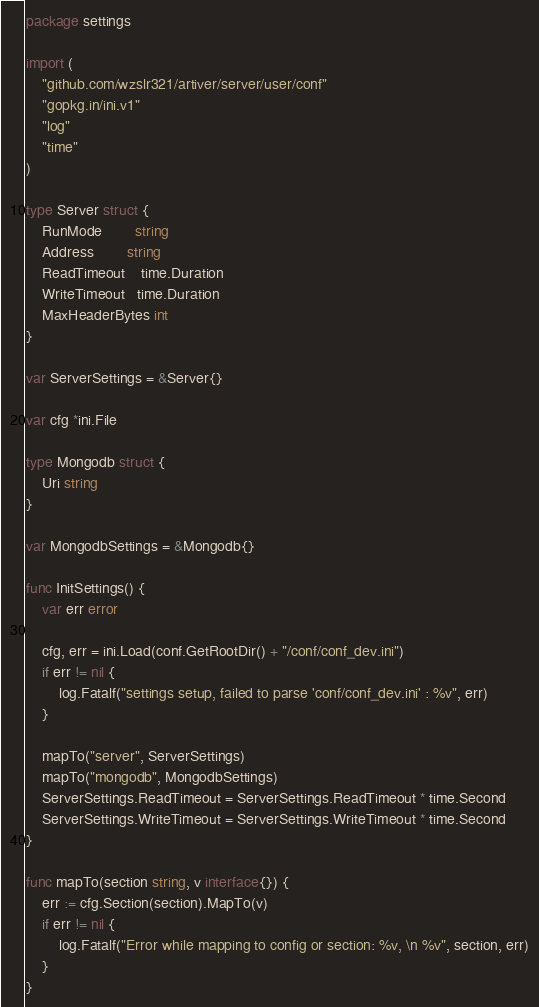<code> <loc_0><loc_0><loc_500><loc_500><_Go_>package settings

import (
	"github.com/wzslr321/artiver/server/user/conf"
	"gopkg.in/ini.v1"
	"log"
	"time"
)

type Server struct {
	RunMode        string
	Address        string
	ReadTimeout    time.Duration
	WriteTimeout   time.Duration
	MaxHeaderBytes int
}

var ServerSettings = &Server{}

var cfg *ini.File

type Mongodb struct {
	Uri string
}

var MongodbSettings = &Mongodb{}

func InitSettings() {
	var err error

	cfg, err = ini.Load(conf.GetRootDir() + "/conf/conf_dev.ini")
	if err != nil {
		log.Fatalf("settings setup, failed to parse 'conf/conf_dev.ini' : %v", err)
	}

	mapTo("server", ServerSettings)
	mapTo("mongodb", MongodbSettings)
	ServerSettings.ReadTimeout = ServerSettings.ReadTimeout * time.Second
	ServerSettings.WriteTimeout = ServerSettings.WriteTimeout * time.Second
}

func mapTo(section string, v interface{}) {
	err := cfg.Section(section).MapTo(v)
	if err != nil {
		log.Fatalf("Error while mapping to config or section: %v, \n %v", section, err)
	}
}
</code> 